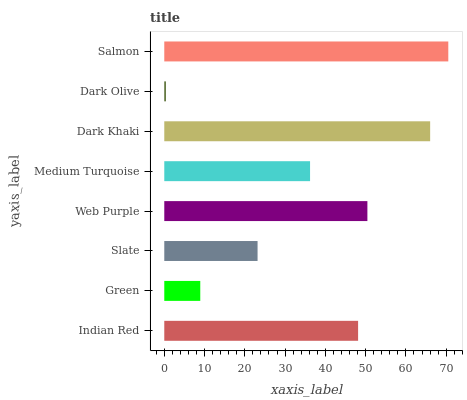Is Dark Olive the minimum?
Answer yes or no. Yes. Is Salmon the maximum?
Answer yes or no. Yes. Is Green the minimum?
Answer yes or no. No. Is Green the maximum?
Answer yes or no. No. Is Indian Red greater than Green?
Answer yes or no. Yes. Is Green less than Indian Red?
Answer yes or no. Yes. Is Green greater than Indian Red?
Answer yes or no. No. Is Indian Red less than Green?
Answer yes or no. No. Is Indian Red the high median?
Answer yes or no. Yes. Is Medium Turquoise the low median?
Answer yes or no. Yes. Is Dark Khaki the high median?
Answer yes or no. No. Is Slate the low median?
Answer yes or no. No. 